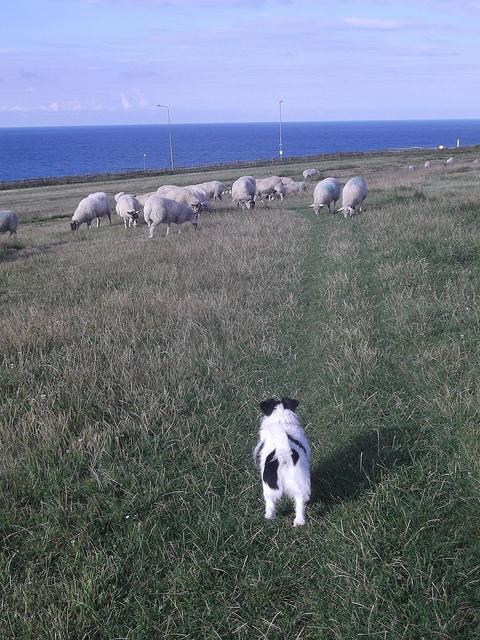What animal is facing the herd?
Make your selection from the four choices given to correctly answer the question.
Options: Rabbit, cat, fox, dog. Dog. 